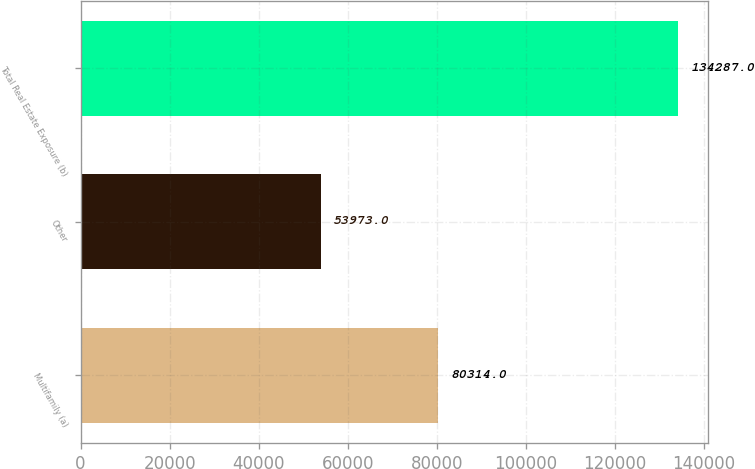Convert chart. <chart><loc_0><loc_0><loc_500><loc_500><bar_chart><fcel>Multifamily (a)<fcel>Other<fcel>Total Real Estate Exposure (b)<nl><fcel>80314<fcel>53973<fcel>134287<nl></chart> 